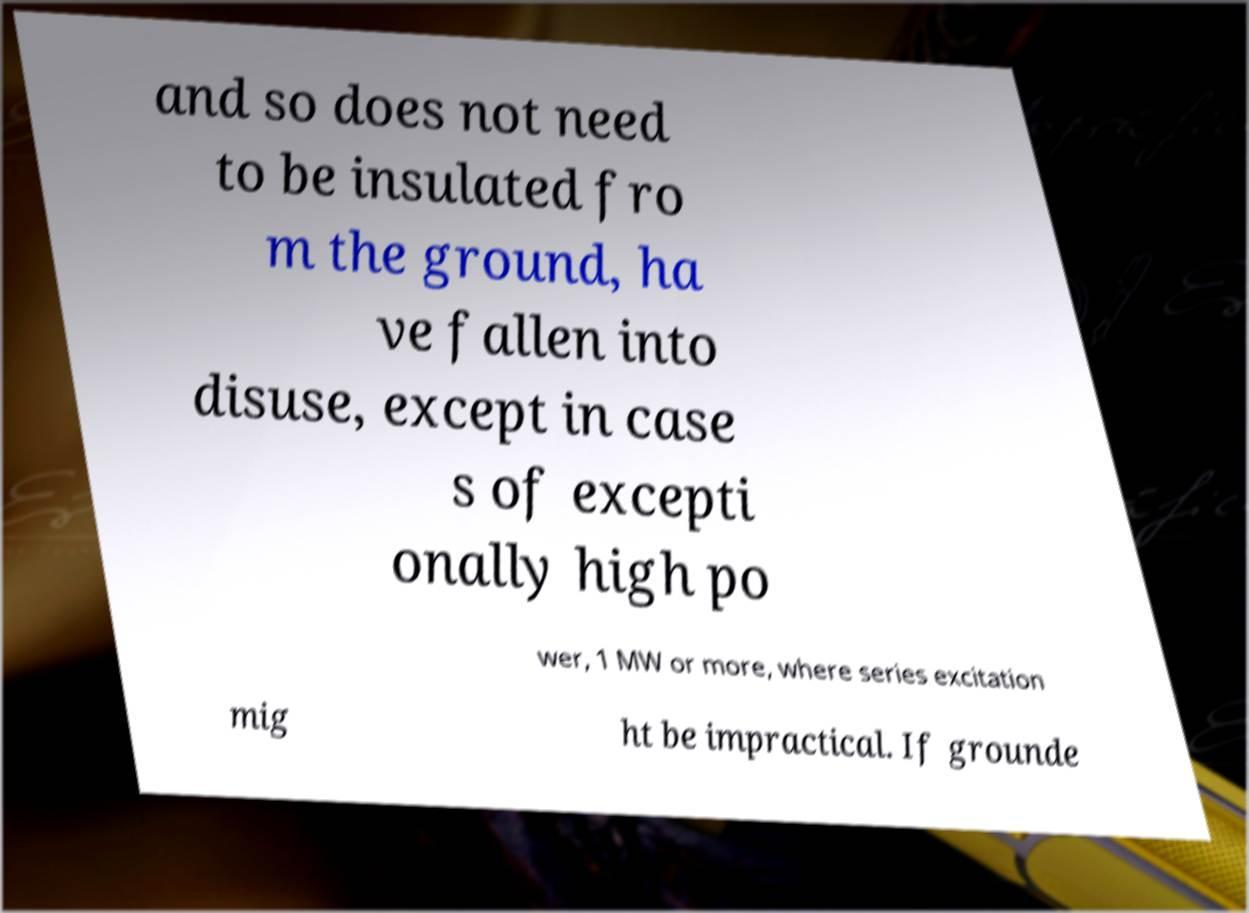Could you extract and type out the text from this image? and so does not need to be insulated fro m the ground, ha ve fallen into disuse, except in case s of excepti onally high po wer, 1 MW or more, where series excitation mig ht be impractical. If grounde 